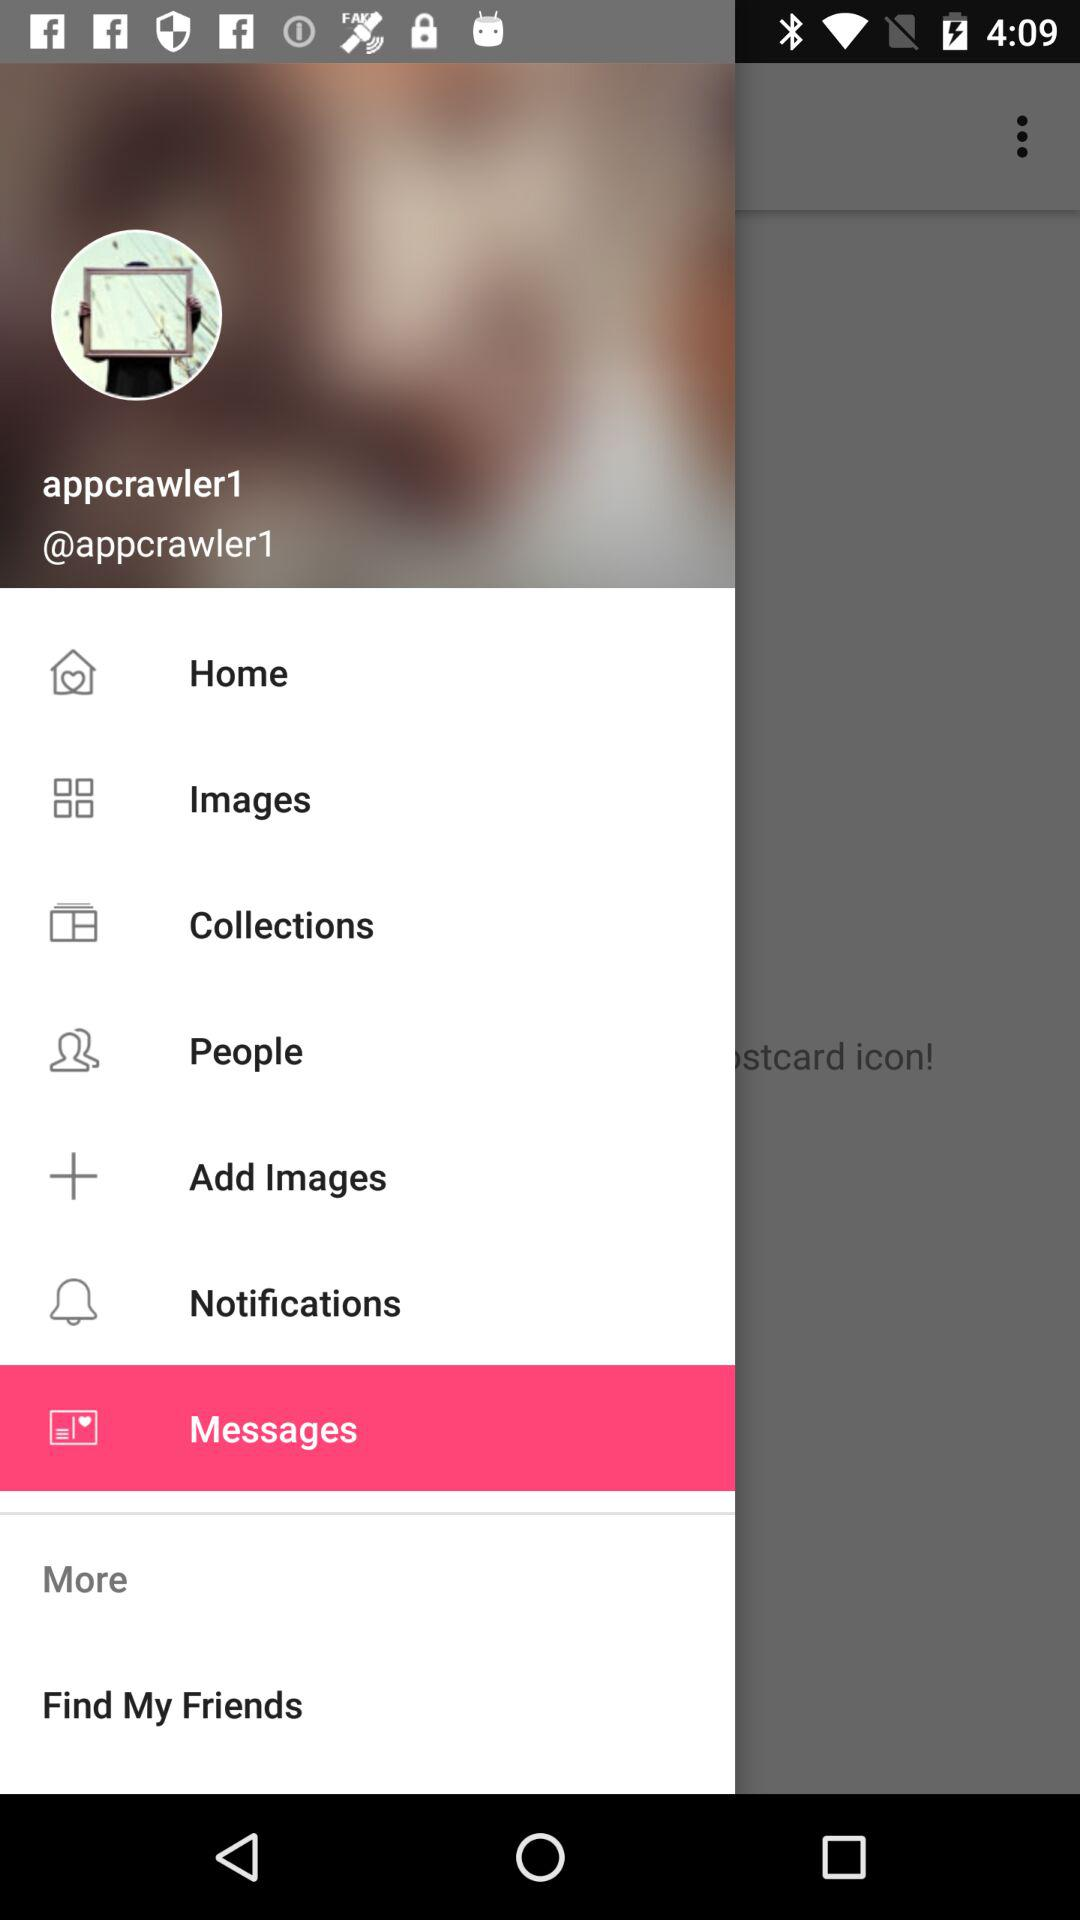What is the user name? The user name is "appcrawler1". 